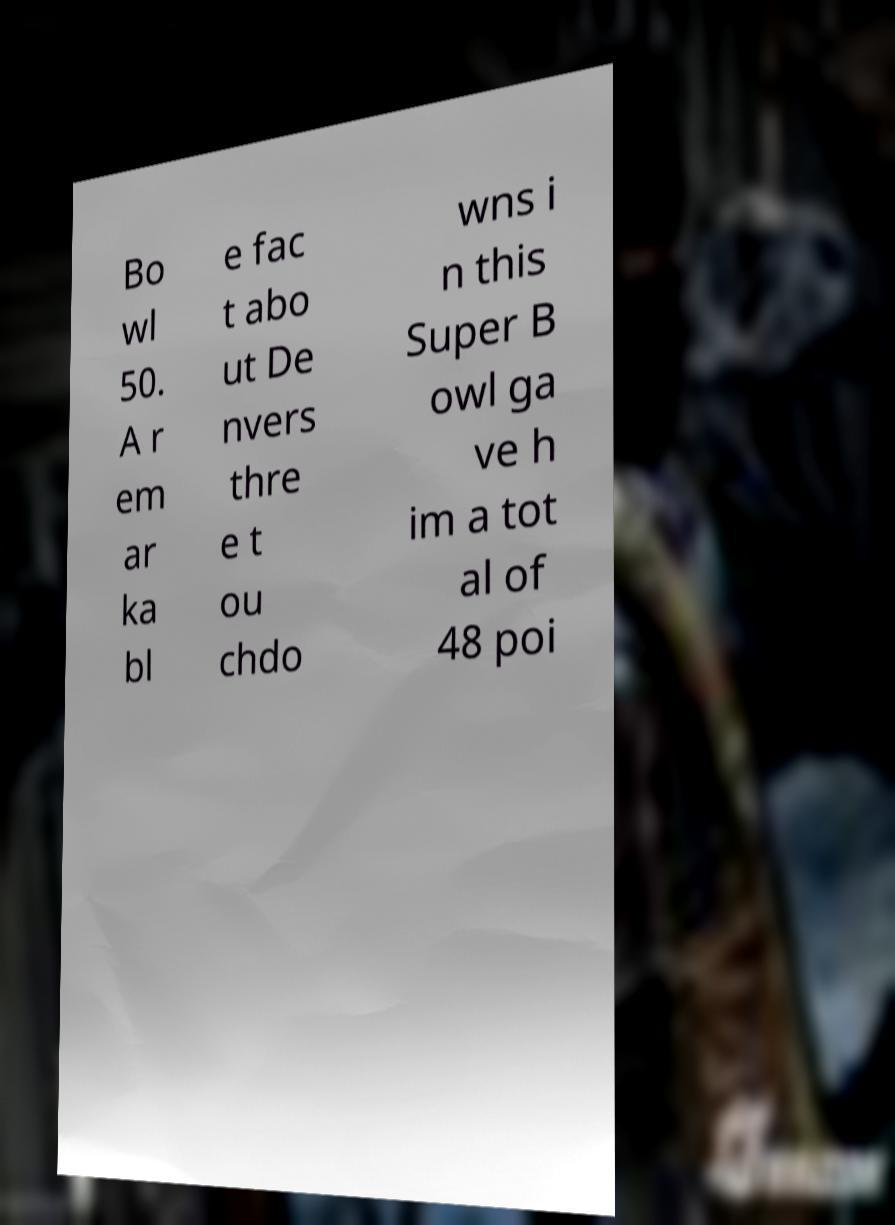For documentation purposes, I need the text within this image transcribed. Could you provide that? Bo wl 50. A r em ar ka bl e fac t abo ut De nvers thre e t ou chdo wns i n this Super B owl ga ve h im a tot al of 48 poi 